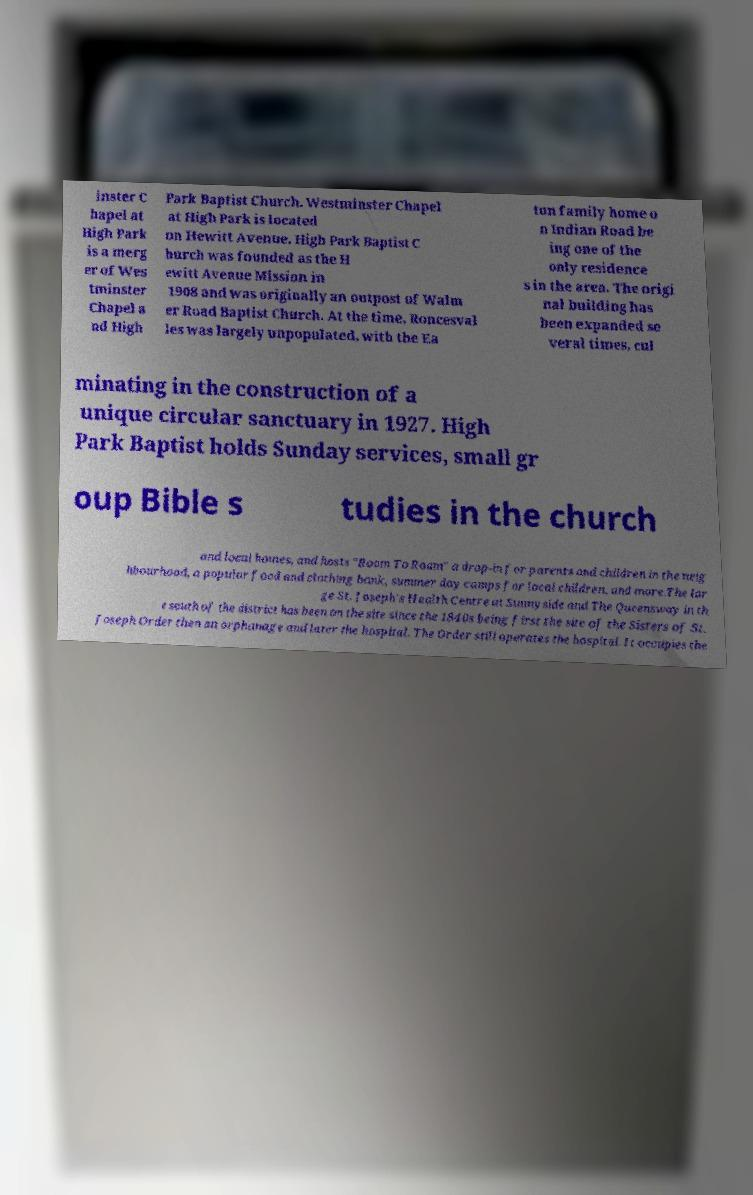Can you accurately transcribe the text from the provided image for me? inster C hapel at High Park is a merg er of Wes tminster Chapel a nd High Park Baptist Church. Westminster Chapel at High Park is located on Hewitt Avenue. High Park Baptist C hurch was founded as the H ewitt Avenue Mission in 1908 and was originally an outpost of Walm er Road Baptist Church. At the time, Roncesval les was largely unpopulated, with the Ea ton family home o n Indian Road be ing one of the only residence s in the area. The origi nal building has been expanded se veral times, cul minating in the construction of a unique circular sanctuary in 1927. High Park Baptist holds Sunday services, small gr oup Bible s tudies in the church and local homes, and hosts "Room To Roam" a drop-in for parents and children in the neig hbourhood, a popular food and clothing bank, summer day camps for local children, and more.The lar ge St. Joseph's Health Centre at Sunnyside and The Queensway in th e south of the district has been on the site since the 1840s being first the site of the Sisters of St. Joseph Order then an orphanage and later the hospital. The Order still operates the hospital. It occupies the 